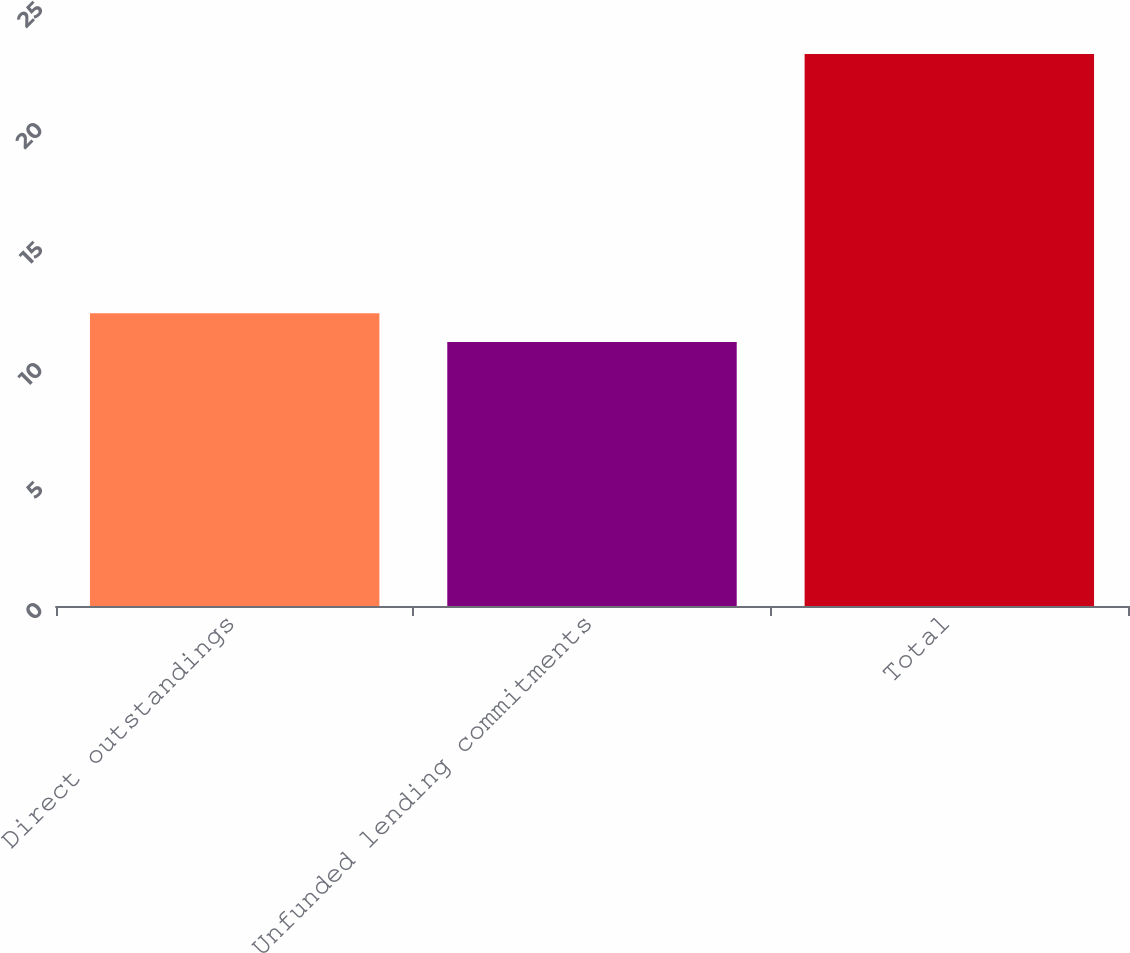Convert chart. <chart><loc_0><loc_0><loc_500><loc_500><bar_chart><fcel>Direct outstandings<fcel>Unfunded lending commitments<fcel>Total<nl><fcel>12.2<fcel>11<fcel>23<nl></chart> 